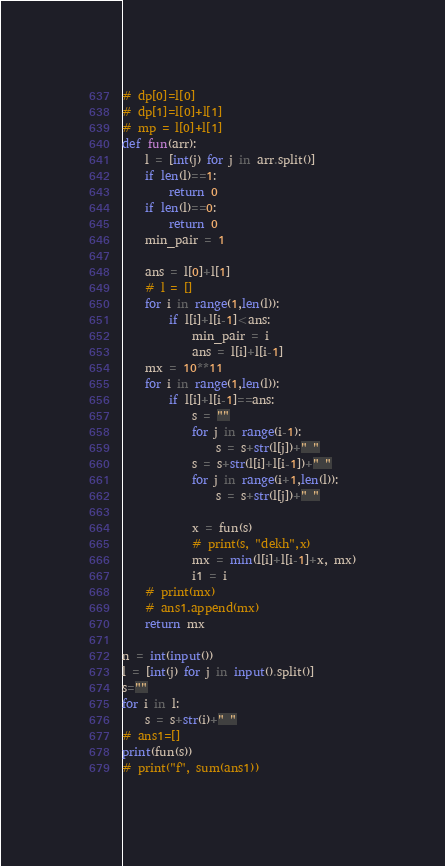<code> <loc_0><loc_0><loc_500><loc_500><_Python_>
# dp[0]=l[0]
# dp[1]=l[0]+l[1]
# mp = l[0]+l[1]
def fun(arr):
    l = [int(j) for j in arr.split()]
    if len(l)==1:
        return 0
    if len(l)==0:
        return 0
    min_pair = 1
    
    ans = l[0]+l[1]
    # l = []
    for i in range(1,len(l)):
        if l[i]+l[i-1]<ans:
            min_pair = i
            ans = l[i]+l[i-1]
    mx = 10**11
    for i in range(1,len(l)):
        if l[i]+l[i-1]==ans:
            s = ""
            for j in range(i-1):
                s = s+str(l[j])+" "
            s = s+str(l[i]+l[i-1])+" "
            for j in range(i+1,len(l)):
                s = s+str(l[j])+" "
            
            x = fun(s)
            # print(s, "dekh",x)
            mx = min(l[i]+l[i-1]+x, mx)
            i1 = i
    # print(mx)
    # ans1.append(mx)
    return mx
        
n = int(input())
l = [int(j) for j in input().split()]
s=""
for i in l:
    s = s+str(i)+" "
# ans1=[]
print(fun(s))
# print("f", sum(ans1))</code> 